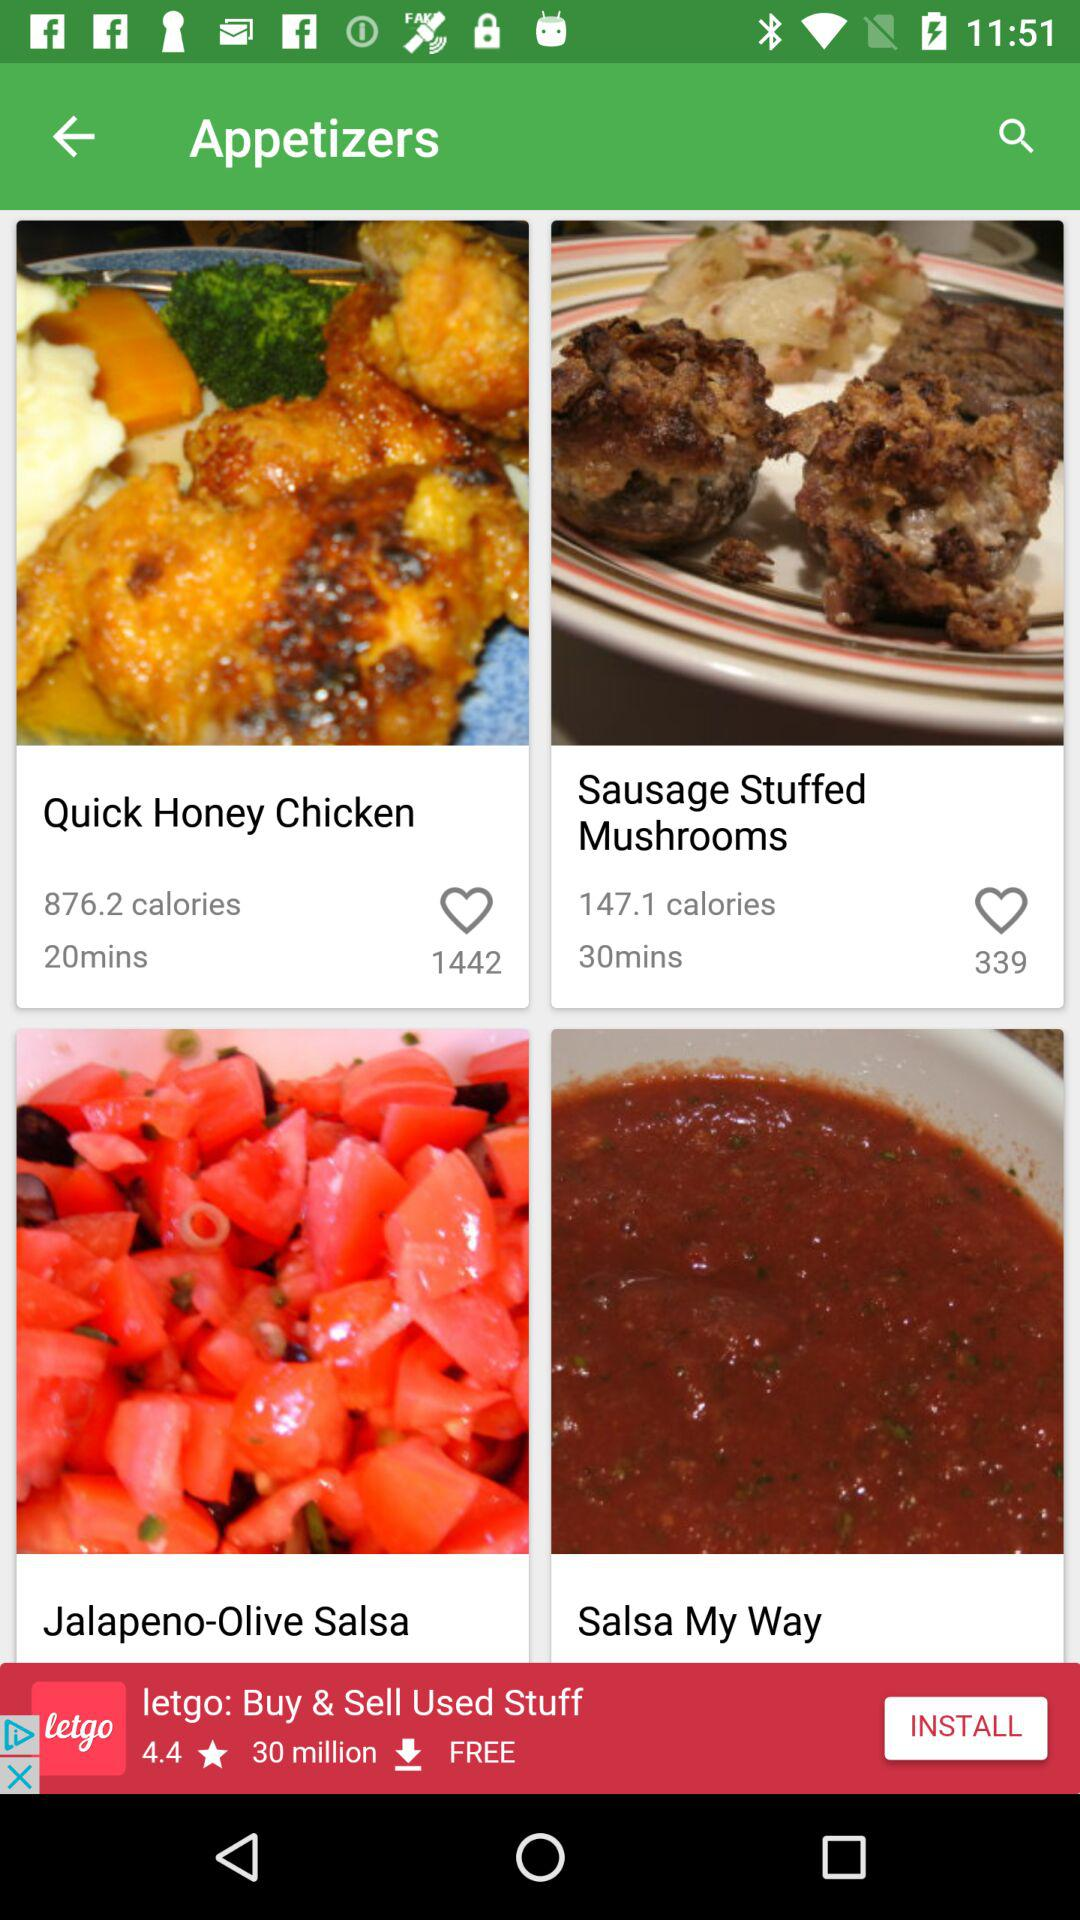What is the calorie count in sausage stuffed mushrooms? The calorie count in sausage stuffed mushrooms is 147.1. 